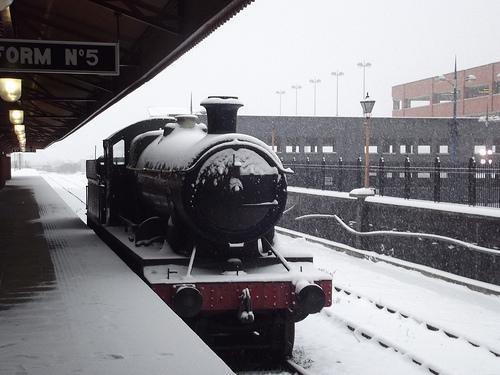How many of the lights are green?
Give a very brief answer. 0. 